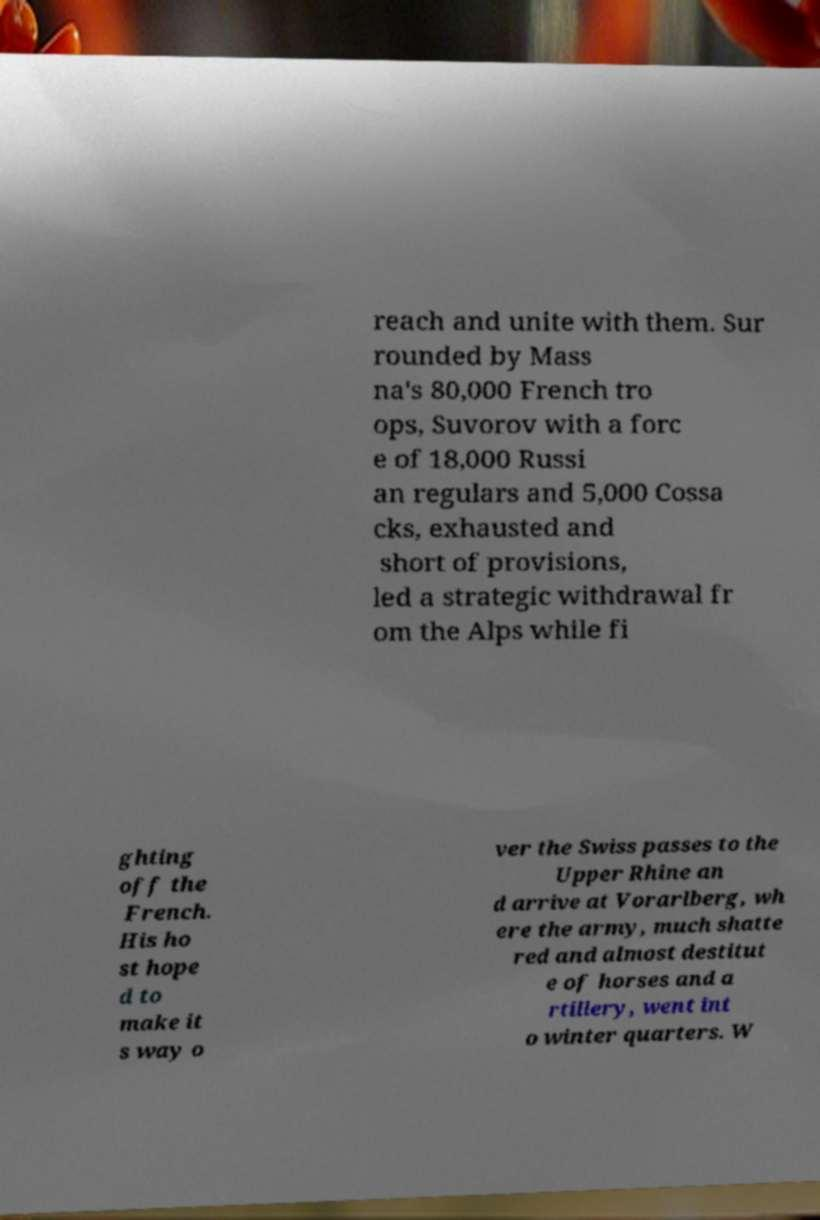Please read and relay the text visible in this image. What does it say? reach and unite with them. Sur rounded by Mass na's 80,000 French tro ops, Suvorov with a forc e of 18,000 Russi an regulars and 5,000 Cossa cks, exhausted and short of provisions, led a strategic withdrawal fr om the Alps while fi ghting off the French. His ho st hope d to make it s way o ver the Swiss passes to the Upper Rhine an d arrive at Vorarlberg, wh ere the army, much shatte red and almost destitut e of horses and a rtillery, went int o winter quarters. W 